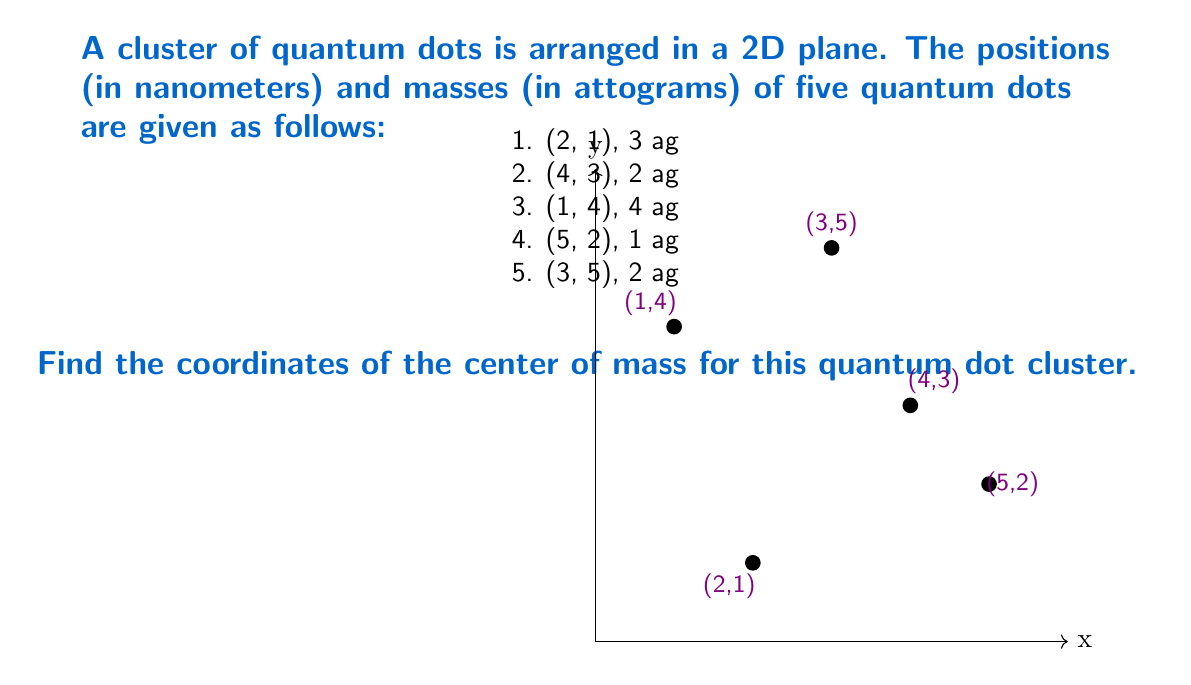Give your solution to this math problem. To find the center of mass for a system of particles, we use the following formulas:

$$x_{cm} = \frac{\sum_{i=1}^n m_i x_i}{\sum_{i=1}^n m_i}$$
$$y_{cm} = \frac{\sum_{i=1}^n m_i y_i}{\sum_{i=1}^n m_i}$$

Where $(x_{cm}, y_{cm})$ are the coordinates of the center of mass, $m_i$ is the mass of each particle, and $(x_i, y_i)$ are the coordinates of each particle.

Step 1: Calculate the total mass of the system.
$M_{total} = 3 + 2 + 4 + 1 + 2 = 12$ ag

Step 2: Calculate $\sum m_i x_i$:
$\sum m_i x_i = (3 \cdot 2) + (2 \cdot 4) + (4 \cdot 1) + (1 \cdot 5) + (2 \cdot 3) = 6 + 8 + 4 + 5 + 6 = 29$ ag·nm

Step 3: Calculate $\sum m_i y_i$:
$\sum m_i y_i = (3 \cdot 1) + (2 \cdot 3) + (4 \cdot 4) + (1 \cdot 2) + (2 \cdot 5) = 3 + 6 + 16 + 2 + 10 = 37$ ag·nm

Step 4: Calculate $x_{cm}$:
$x_{cm} = \frac{29}{12} \approx 2.42$ nm

Step 5: Calculate $y_{cm}$:
$y_{cm} = \frac{37}{12} \approx 3.08$ nm

Therefore, the center of mass is located at approximately (2.42 nm, 3.08 nm).
Answer: (2.42 nm, 3.08 nm) 